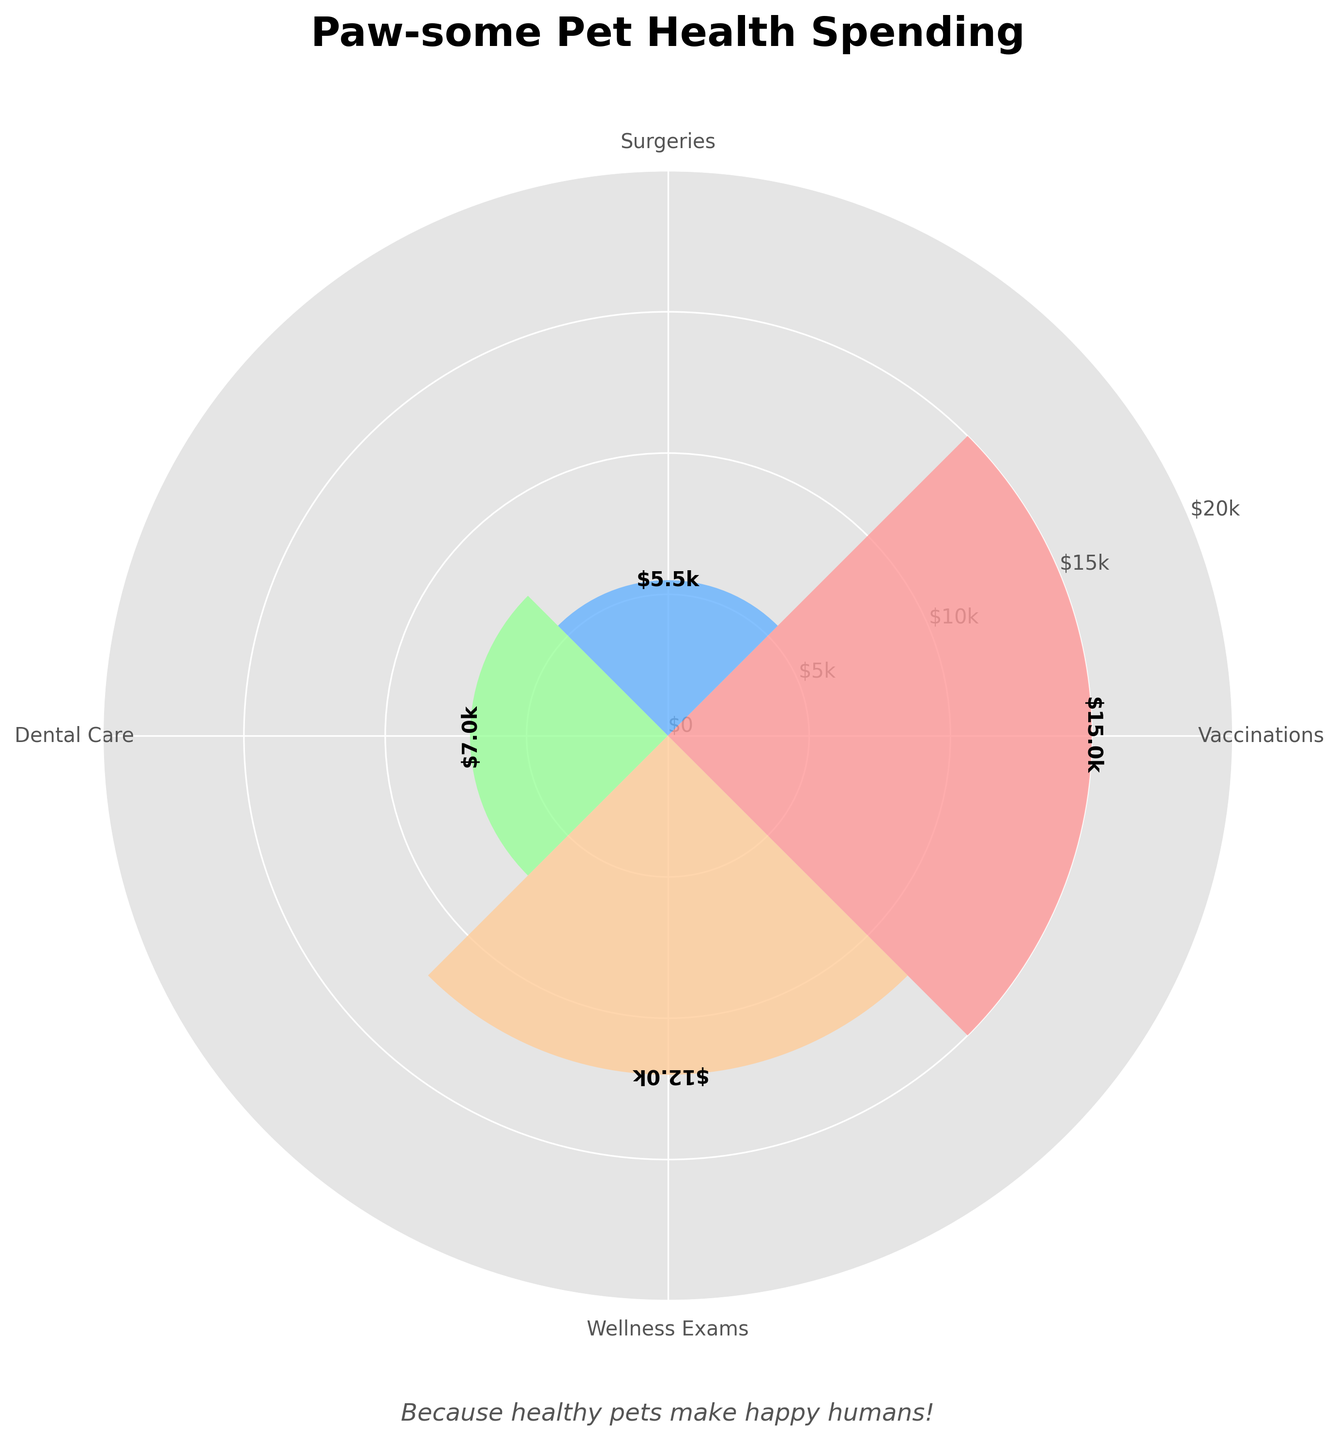What is the title of the chart? The title of the chart is displayed prominently at the top. It reads "Paw-some Pet Health Spending".
Answer: Paw-some Pet Health Spending What are the labels for the categories on the polar chart? The categories are labeled around the chart and include Vaccinations, Surgeries, Dental Care, and Wellness Exams.
Answer: Vaccinations, Surgeries, Dental Care, Wellness Exams Which type of service has the highest spending? The height of the bars in the polar chart represents the spending on each type of service. The highest bar corresponds to Vaccinations.
Answer: Vaccinations How much is spent on Wellness Exams? The label at the top of the bar corresponding to Wellness Exams shows the amount spent. It reads $12k.
Answer: $12k What is the combined spending on Dental Care and Surgeries? To find the total spending on Dental Care and Surgeries, add the two amounts: $7000 for Dental Care and $5500 for Surgeries.
Answer: $12,500 By how much does spending on Wellness Exams exceed spending on Surgeries? Subtract the spending on Surgeries ($5500) from the spending on Wellness Exams ($12,000).
Answer: $6,500 Which category has the smallest spending and what is the amount? The smallest bar on the chart represents Surgeries, with a total spending of $5500.
Answer: Surgeries, $5500 Order the categories from highest to lowest spending. The bar heights indicate the spending amounts. From highest to lowest: Vaccinations, Wellness Exams, Dental Care, Surgeries.
Answer: Vaccinations > Wellness Exams > Dental Care > Surgeries What does the subtitle of the chart say? The subtitle is located beneath the title of the chart. It reads, "Because healthy pets make happy humans!".
Answer: Because healthy pets make happy humans! 